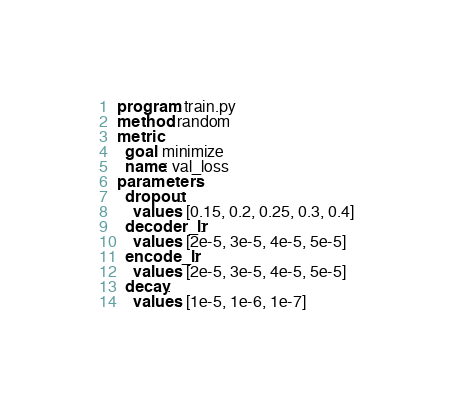<code> <loc_0><loc_0><loc_500><loc_500><_YAML_>program: train.py
method: random
metric:
  goal: minimize
  name: val_loss
parameters:
  dropout:
    values: [0.15, 0.2, 0.25, 0.3, 0.4]
  decoder_lr:
    values: [2e-5, 3e-5, 4e-5, 5e-5]
  encode_lr:
    values: [2e-5, 3e-5, 4e-5, 5e-5]
  decay:
    values: [1e-5, 1e-6, 1e-7]
</code> 